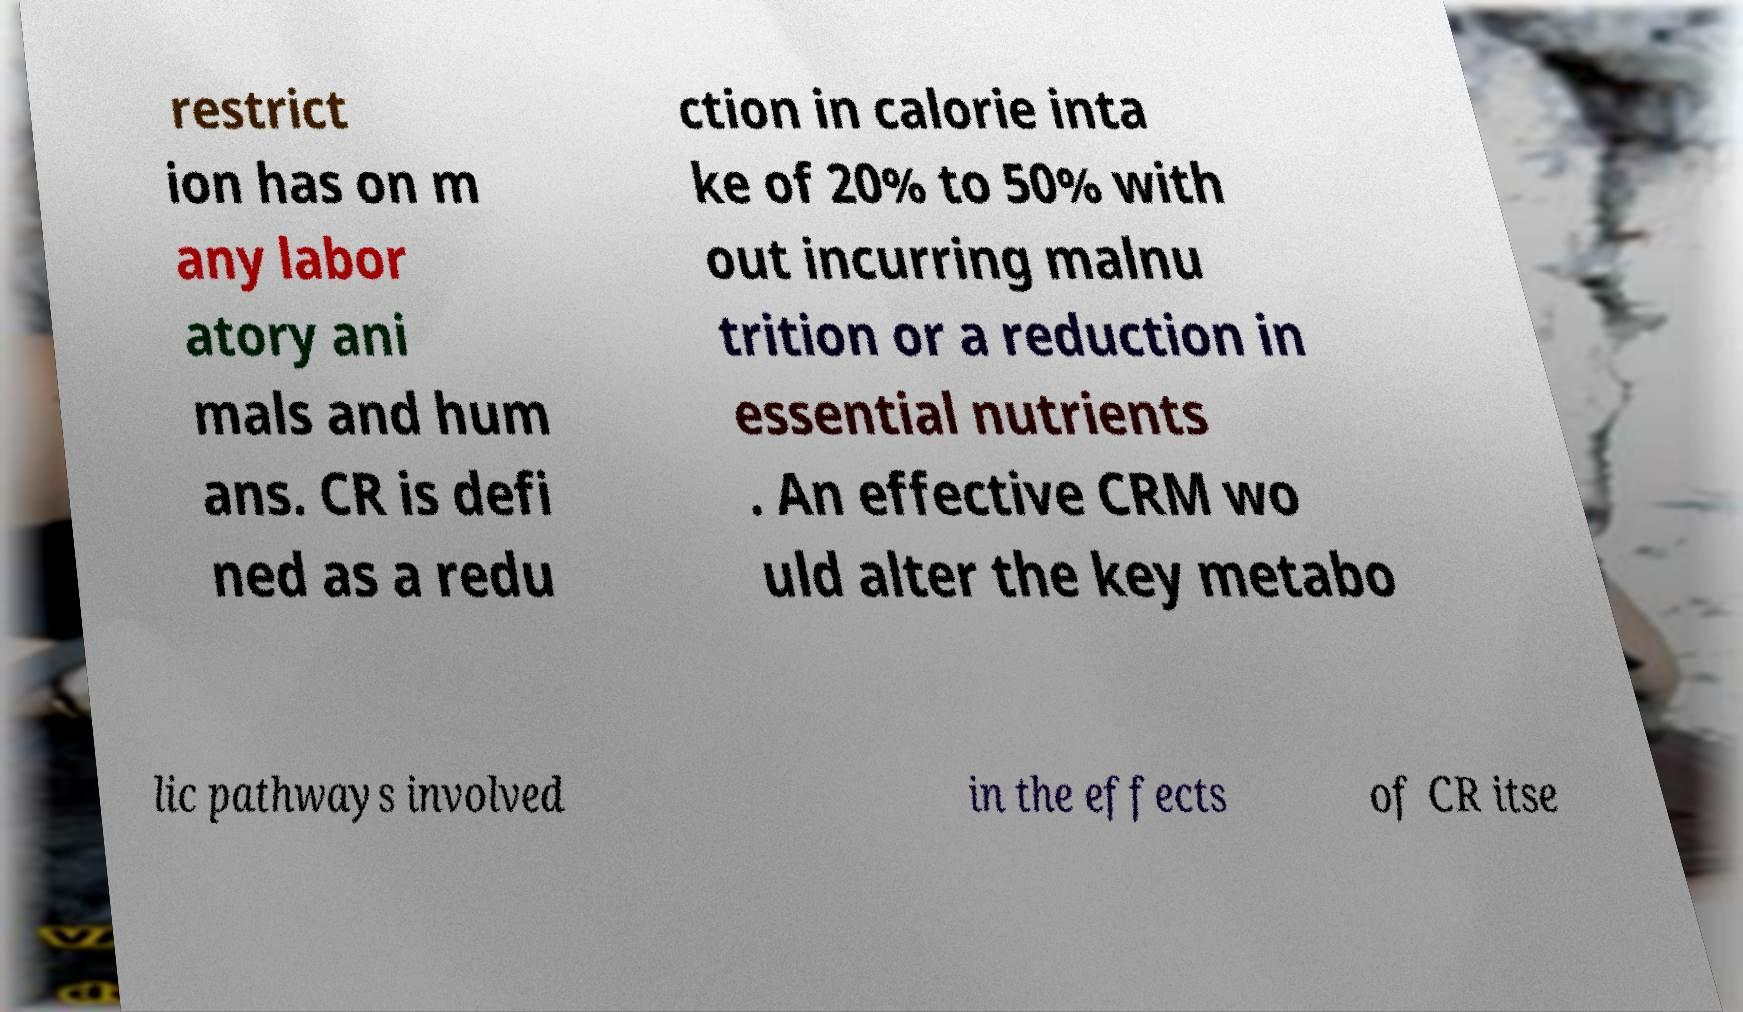Can you accurately transcribe the text from the provided image for me? restrict ion has on m any labor atory ani mals and hum ans. CR is defi ned as a redu ction in calorie inta ke of 20% to 50% with out incurring malnu trition or a reduction in essential nutrients . An effective CRM wo uld alter the key metabo lic pathways involved in the effects of CR itse 